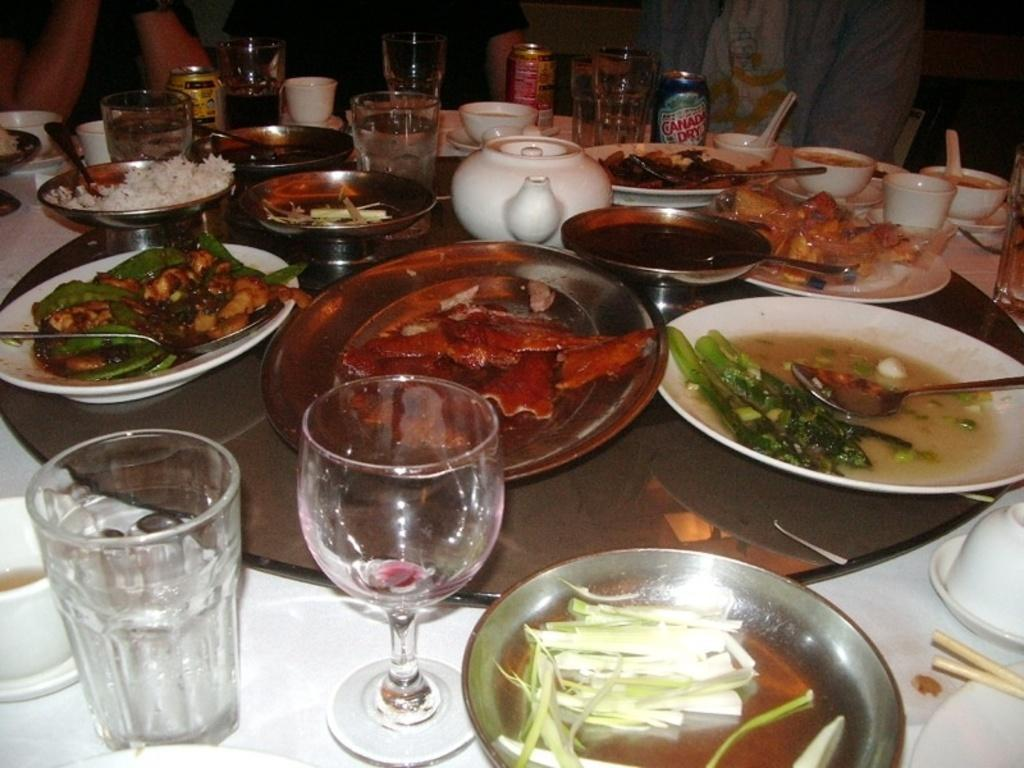What type of furniture is in the image? There is a table in the image. What items are on the table? Glasses, plates, spoons, and bowls are on the table. What is on the table that indicates food is being served? There is food on the table. Can you describe the people in the image? There are persons visible in the center of the image. How are the persons in the image sorting the truck? There is no truck present in the image, and therefore no sorting activity can be observed. 